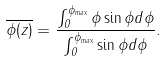Convert formula to latex. <formula><loc_0><loc_0><loc_500><loc_500>\overline { \phi ( z ) } = \frac { \int _ { 0 } ^ { \phi _ { \max } } \phi \sin \phi d \phi } { \int _ { 0 } ^ { \phi _ { \max } } \sin \phi d \phi } .</formula> 